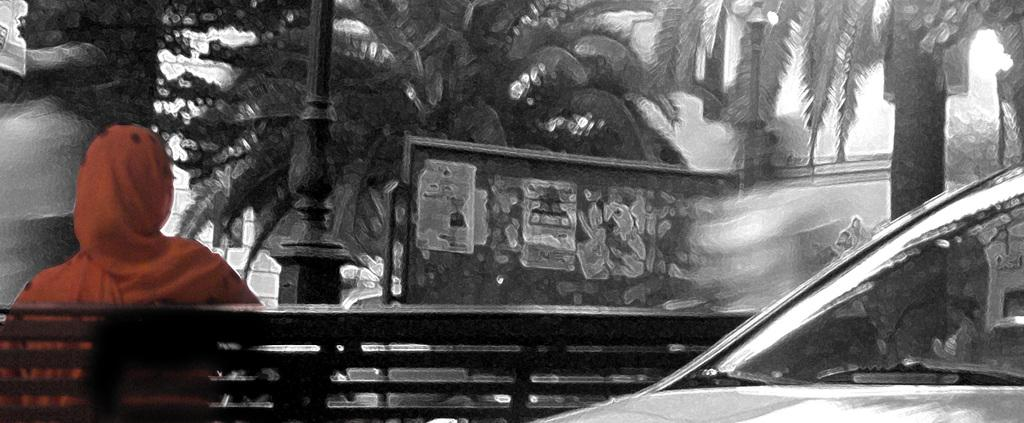What type of artwork is depicted in the image? The image is a painting. What is the main subject of the painting? There is a man sitting on a bench in the center of the painting. What can be seen in the background of the painting? There are trees in the background of the painting. Can you describe any other objects or features in the painting? There is a pole in the painting, which is black in color. How many pizzas are being served on the ground in the image? There are no pizzas or ground present in the image; it is a painting of a man sitting on a bench with trees in the background and a black pole. 